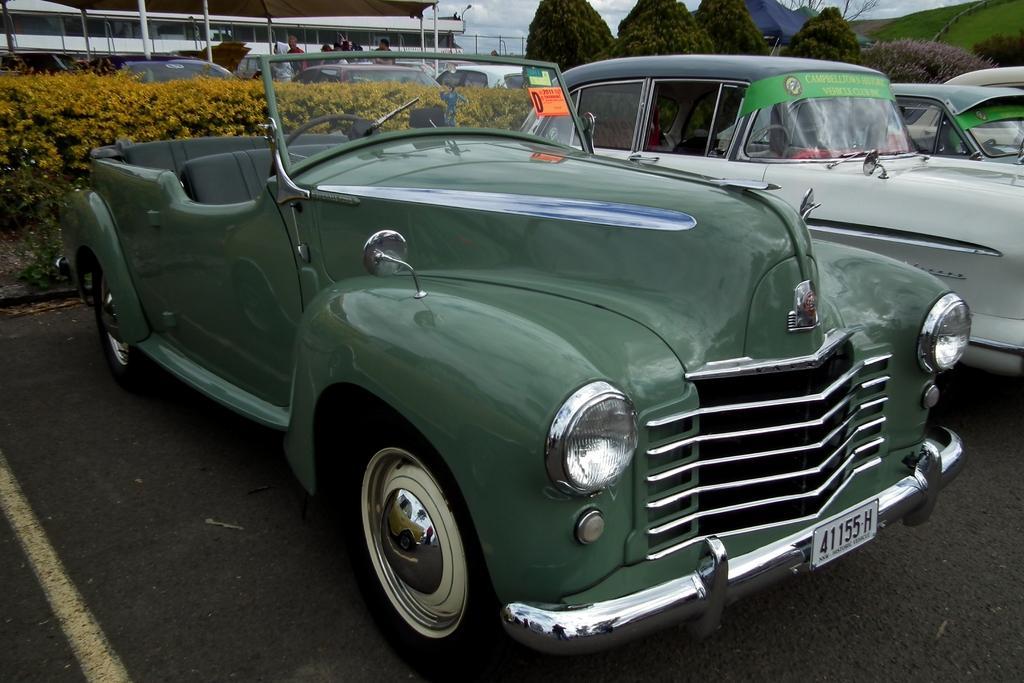In one or two sentences, can you explain what this image depicts? In this picture we can see cars on the road, plants, trees, tents, fence, grass, shelter and a group of people standing and some objects and in the background we can see the sky. 